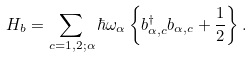<formula> <loc_0><loc_0><loc_500><loc_500>H _ { b } = \sum _ { c = 1 , 2 ; \alpha } \hbar { \omega } _ { \alpha } \left \{ b _ { \alpha , c } ^ { \dag } b _ { \alpha , c } + \frac { 1 } { 2 } \right \} .</formula> 